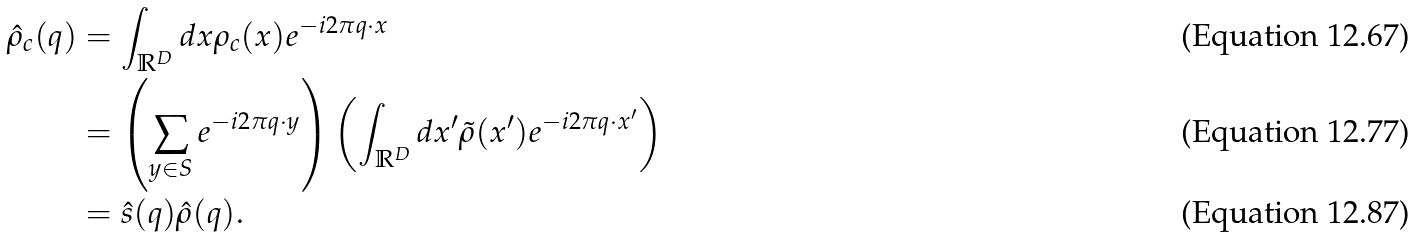Convert formula to latex. <formula><loc_0><loc_0><loc_500><loc_500>\hat { \rho } _ { c } ( q ) & = \int _ { \mathbb { R } ^ { D } } d x \rho _ { c } ( x ) e ^ { - i 2 \pi q \cdot x } \\ & = \left ( \sum _ { y \in S } e ^ { - i 2 \pi q \cdot y } \right ) \left ( \int _ { \mathbb { R } ^ { D } } d x ^ { \prime } \tilde { \rho } ( x ^ { \prime } ) e ^ { - i 2 \pi q \cdot x ^ { \prime } } \right ) \\ & = \hat { s } ( q ) \hat { \rho } ( q ) .</formula> 